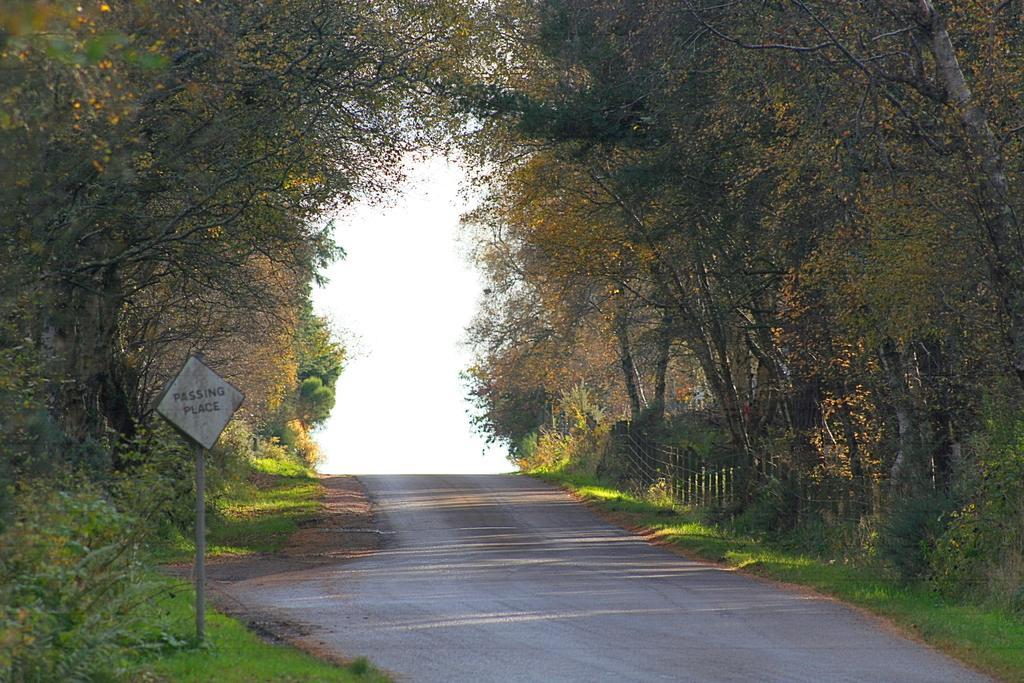Please provide a concise description of this image. At the bottom of this image there is a road. On both sides of the road, I can see the grass and many trees. On the left side there is a pole to which a board is attached. In the background, I can see the sky. 